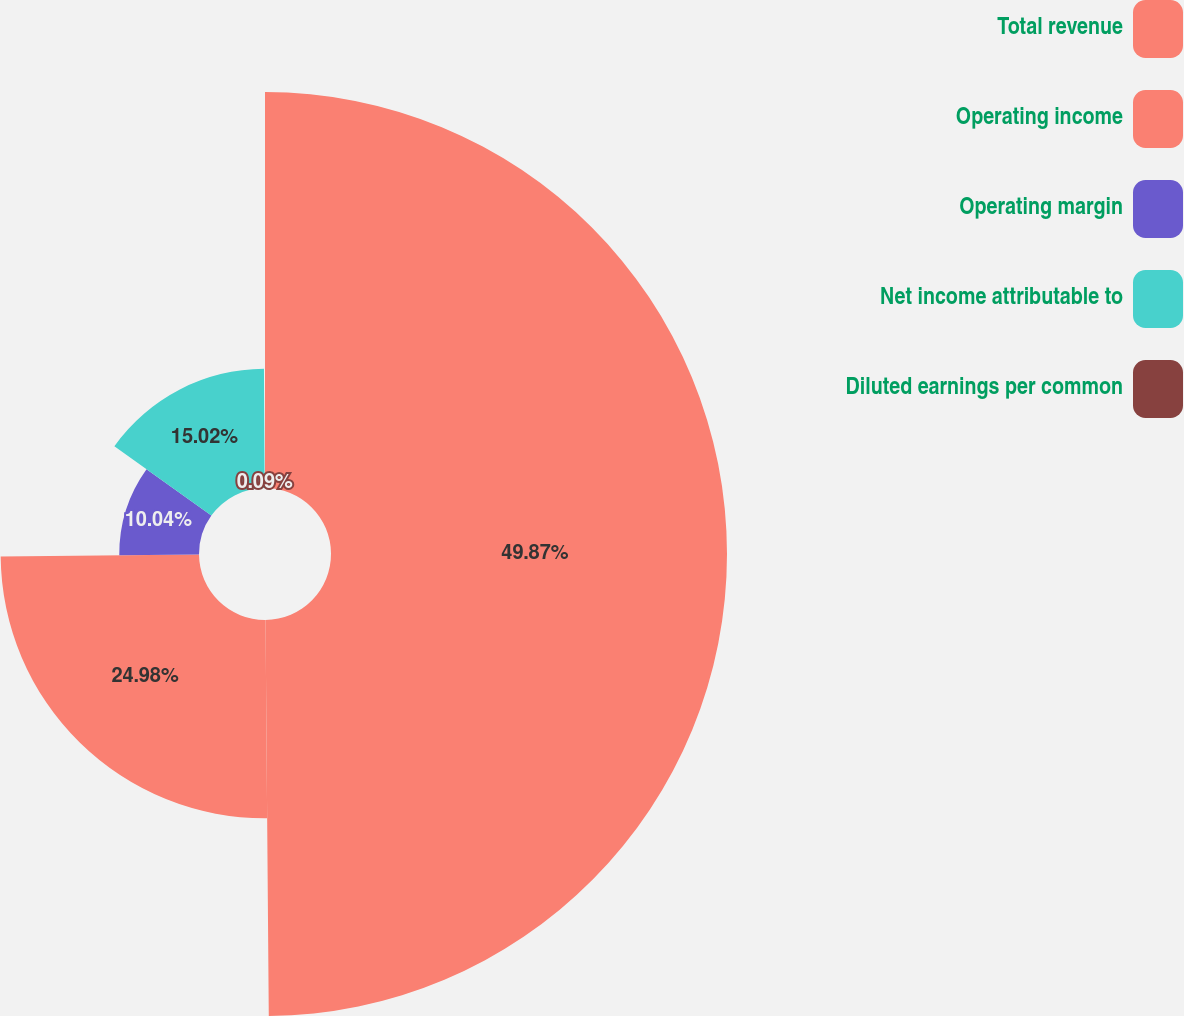Convert chart to OTSL. <chart><loc_0><loc_0><loc_500><loc_500><pie_chart><fcel>Total revenue<fcel>Operating income<fcel>Operating margin<fcel>Net income attributable to<fcel>Diluted earnings per common<nl><fcel>49.87%<fcel>24.98%<fcel>10.04%<fcel>15.02%<fcel>0.09%<nl></chart> 